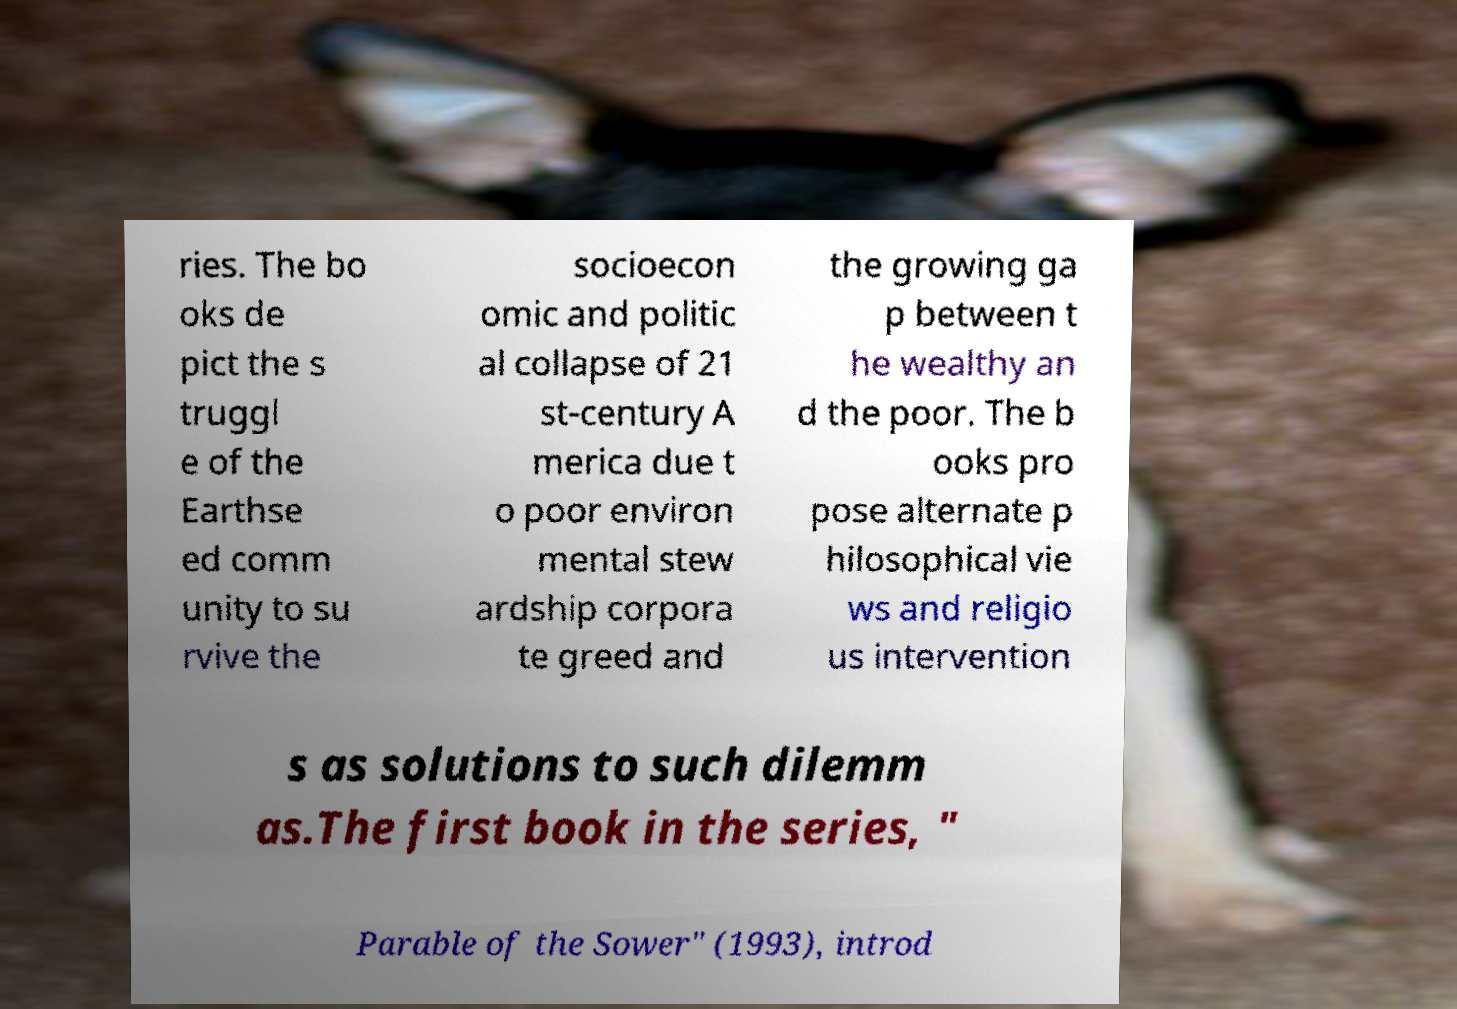Can you accurately transcribe the text from the provided image for me? ries. The bo oks de pict the s truggl e of the Earthse ed comm unity to su rvive the socioecon omic and politic al collapse of 21 st-century A merica due t o poor environ mental stew ardship corpora te greed and the growing ga p between t he wealthy an d the poor. The b ooks pro pose alternate p hilosophical vie ws and religio us intervention s as solutions to such dilemm as.The first book in the series, " Parable of the Sower" (1993), introd 